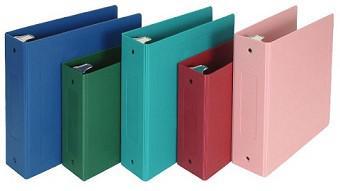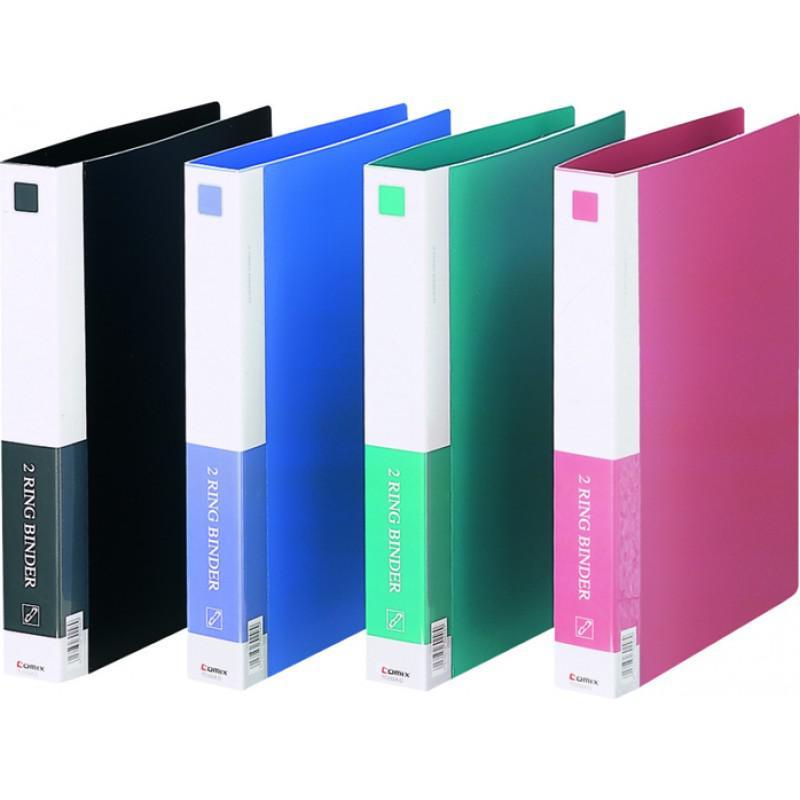The first image is the image on the left, the second image is the image on the right. Assess this claim about the two images: "There are exactly nine binders in the pair of images.". Correct or not? Answer yes or no. Yes. The first image is the image on the left, the second image is the image on the right. For the images displayed, is the sentence "Here, we see a total of nine binders." factually correct? Answer yes or no. Yes. 